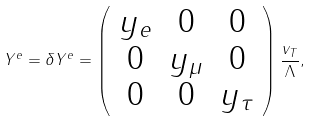Convert formula to latex. <formula><loc_0><loc_0><loc_500><loc_500>Y ^ { e } = \delta Y ^ { e } = \left ( \begin{array} { c c c } y _ { e } & 0 & 0 \\ 0 & y _ { \mu } & 0 \\ 0 & 0 & y _ { \tau } \\ \end{array} \right ) \frac { v _ { T } } { \Lambda } ,</formula> 